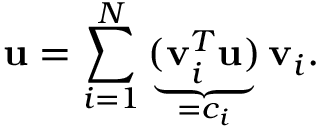Convert formula to latex. <formula><loc_0><loc_0><loc_500><loc_500>u = \sum _ { i = 1 } ^ { N } \underbrace { ( v _ { i } ^ { T } u ) } _ { = c _ { i } } v _ { i } .</formula> 